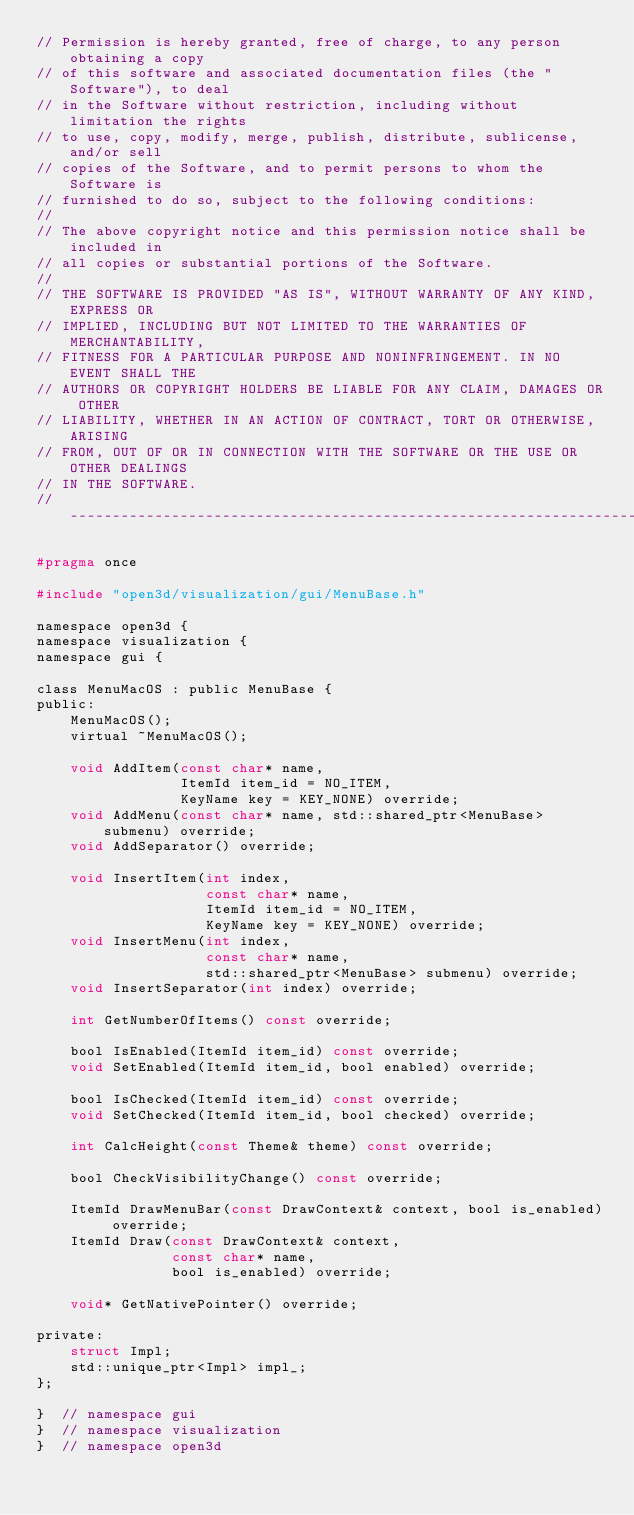<code> <loc_0><loc_0><loc_500><loc_500><_C_>// Permission is hereby granted, free of charge, to any person obtaining a copy
// of this software and associated documentation files (the "Software"), to deal
// in the Software without restriction, including without limitation the rights
// to use, copy, modify, merge, publish, distribute, sublicense, and/or sell
// copies of the Software, and to permit persons to whom the Software is
// furnished to do so, subject to the following conditions:
//
// The above copyright notice and this permission notice shall be included in
// all copies or substantial portions of the Software.
//
// THE SOFTWARE IS PROVIDED "AS IS", WITHOUT WARRANTY OF ANY KIND, EXPRESS OR
// IMPLIED, INCLUDING BUT NOT LIMITED TO THE WARRANTIES OF MERCHANTABILITY,
// FITNESS FOR A PARTICULAR PURPOSE AND NONINFRINGEMENT. IN NO EVENT SHALL THE
// AUTHORS OR COPYRIGHT HOLDERS BE LIABLE FOR ANY CLAIM, DAMAGES OR OTHER
// LIABILITY, WHETHER IN AN ACTION OF CONTRACT, TORT OR OTHERWISE, ARISING
// FROM, OUT OF OR IN CONNECTION WITH THE SOFTWARE OR THE USE OR OTHER DEALINGS
// IN THE SOFTWARE.
// ----------------------------------------------------------------------------

#pragma once

#include "open3d/visualization/gui/MenuBase.h"

namespace open3d {
namespace visualization {
namespace gui {

class MenuMacOS : public MenuBase {
public:
    MenuMacOS();
    virtual ~MenuMacOS();

    void AddItem(const char* name,
                 ItemId item_id = NO_ITEM,
                 KeyName key = KEY_NONE) override;
    void AddMenu(const char* name, std::shared_ptr<MenuBase> submenu) override;
    void AddSeparator() override;

    void InsertItem(int index,
                    const char* name,
                    ItemId item_id = NO_ITEM,
                    KeyName key = KEY_NONE) override;
    void InsertMenu(int index,
                    const char* name,
                    std::shared_ptr<MenuBase> submenu) override;
    void InsertSeparator(int index) override;

    int GetNumberOfItems() const override;

    bool IsEnabled(ItemId item_id) const override;
    void SetEnabled(ItemId item_id, bool enabled) override;

    bool IsChecked(ItemId item_id) const override;
    void SetChecked(ItemId item_id, bool checked) override;

    int CalcHeight(const Theme& theme) const override;

    bool CheckVisibilityChange() const override;

    ItemId DrawMenuBar(const DrawContext& context, bool is_enabled) override;
    ItemId Draw(const DrawContext& context,
                const char* name,
                bool is_enabled) override;

    void* GetNativePointer() override;

private:
    struct Impl;
    std::unique_ptr<Impl> impl_;
};

}  // namespace gui
}  // namespace visualization
}  // namespace open3d
</code> 